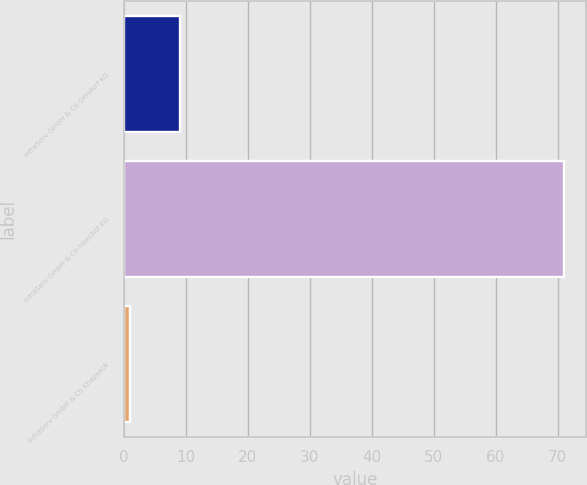Convert chart. <chart><loc_0><loc_0><loc_500><loc_500><bar_chart><fcel>InfraServ GmbH & Co Gendorf KG<fcel>InfraServ GmbH & Co Hoechst KG<fcel>InfraServ GmbH & Co Knapsack<nl><fcel>9<fcel>71<fcel>1<nl></chart> 